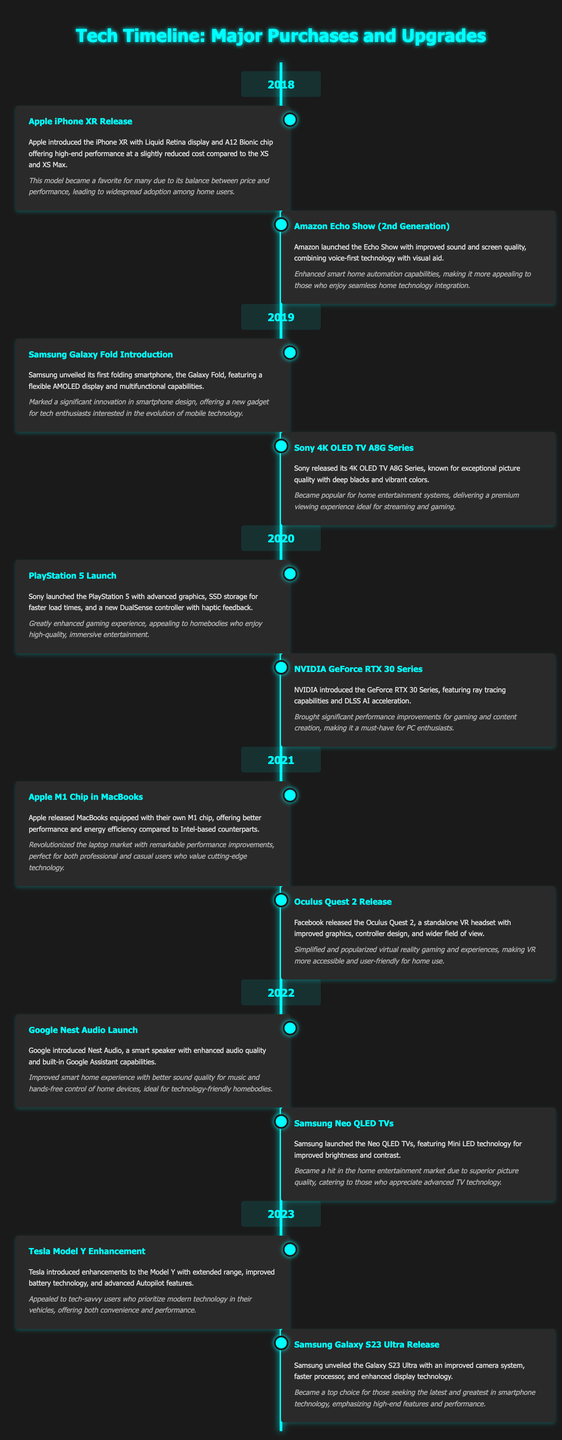What year was the iPhone XR released? The iPhone XR was released in 2018 according to the timeline.
Answer: 2018 Which company launched the Oculus Quest 2? The Oculus Quest 2 was released by Facebook in 2021 according to the document.
Answer: Facebook What feature improved in the Samsung Galaxy S23 Ultra compared to its predecessor? The Galaxy S23 Ultra features an improved camera system, according to the timeline.
Answer: Improved camera system How many major tech events are listed for the year 2020? The document mentions two major tech events for the year 2020.
Answer: Two Which product is involved in enhancing the home entertainment experience in 2022? Google Nest Audio, which improved smart home experience with better sound quality, is mentioned in 2022.
Answer: Google Nest Audio What technology did Samsung's Neo QLED TVs introduce? Neo QLED TVs introduced Mini LED technology for improved brightness and contrast.
Answer: Mini LED technology Which gaming console was launched in 2020? The PlayStation 5 was launched in 2020 according to the document.
Answer: PlayStation 5 What is the overarching theme of the timeline? The timeline showcases major tech purchases and upgrades over the last five years.
Answer: Major tech purchases and upgrades 